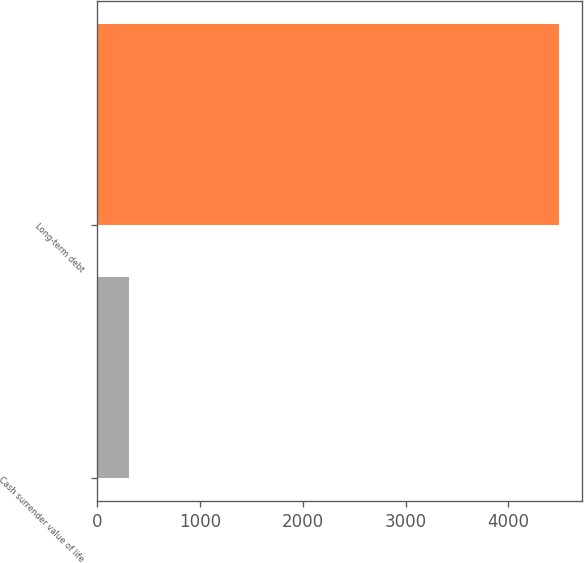Convert chart. <chart><loc_0><loc_0><loc_500><loc_500><bar_chart><fcel>Cash surrender value of life<fcel>Long-term debt<nl><fcel>315<fcel>4488<nl></chart> 